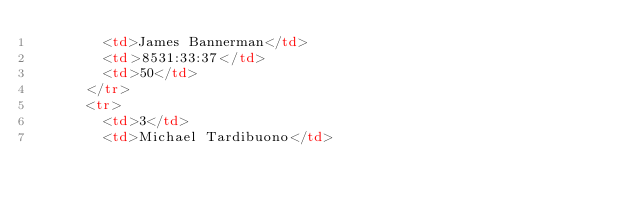<code> <loc_0><loc_0><loc_500><loc_500><_HTML_>        <td>James Bannerman</td>
        <td>8531:33:37</td>
        <td>50</td>
      </tr>
      <tr>
        <td>3</td>
        <td>Michael Tardibuono</td></code> 